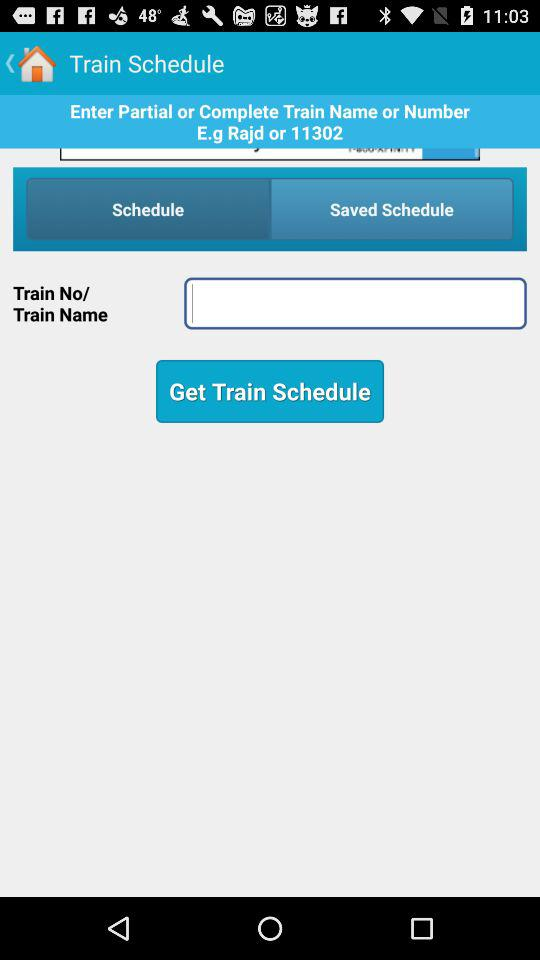What is the application name?
When the provided information is insufficient, respond with <no answer>. <no answer> 